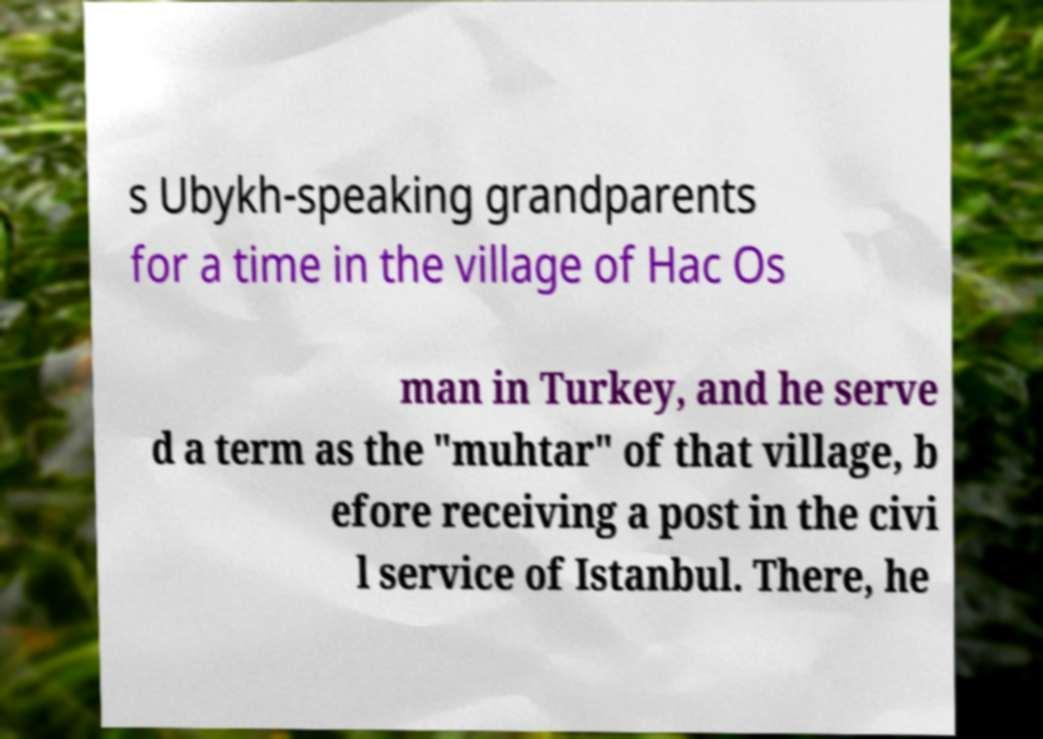Could you assist in decoding the text presented in this image and type it out clearly? s Ubykh-speaking grandparents for a time in the village of Hac Os man in Turkey, and he serve d a term as the "muhtar" of that village, b efore receiving a post in the civi l service of Istanbul. There, he 